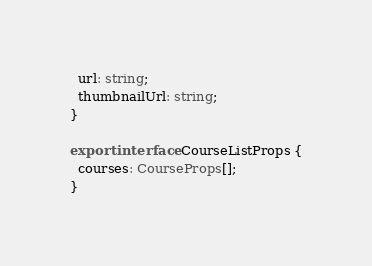<code> <loc_0><loc_0><loc_500><loc_500><_TypeScript_>  url: string;
  thumbnailUrl: string;
}

export interface CourseListProps {
  courses: CourseProps[];
}</code> 